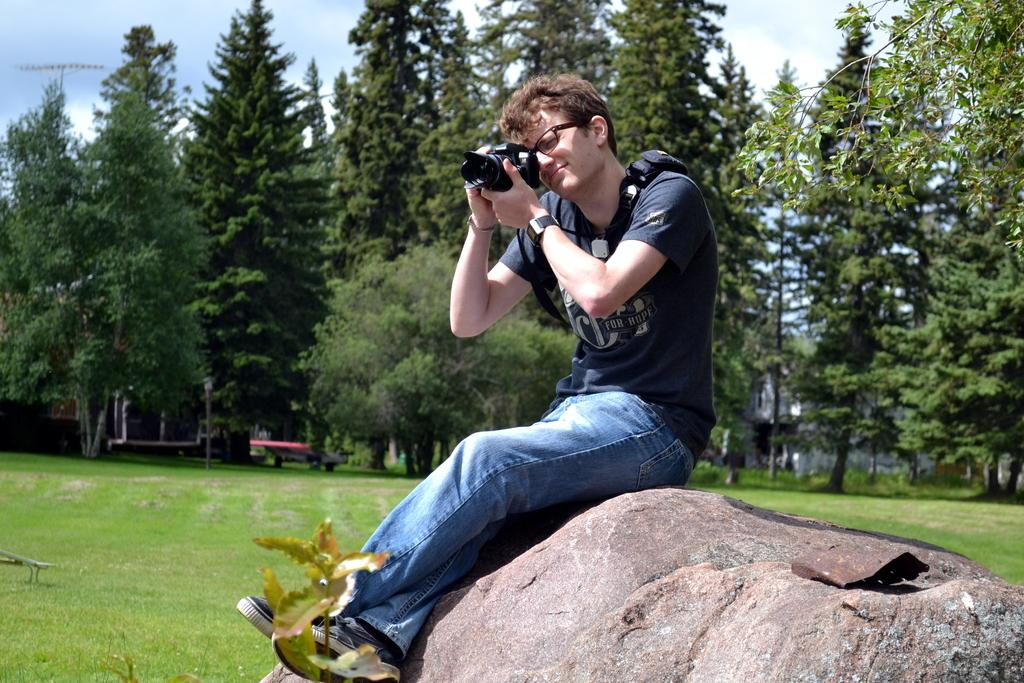What is the person in the image doing? The person is sitting and capturing an image with a camera. What can be seen near the person in the image? There are trees near the person. What is visible in the sky in the image? The sky is visible and clear in the image. What type of exchange is happening between the person and the trees in the image? There is no exchange happening between the person and the trees in the image. How does the person rub the trees in the image? The person is not rubbing the trees in the image; they are capturing an image with a camera. Can you see a hole in the sky in the image? There is no hole visible in the sky in the image; the sky is clear. 